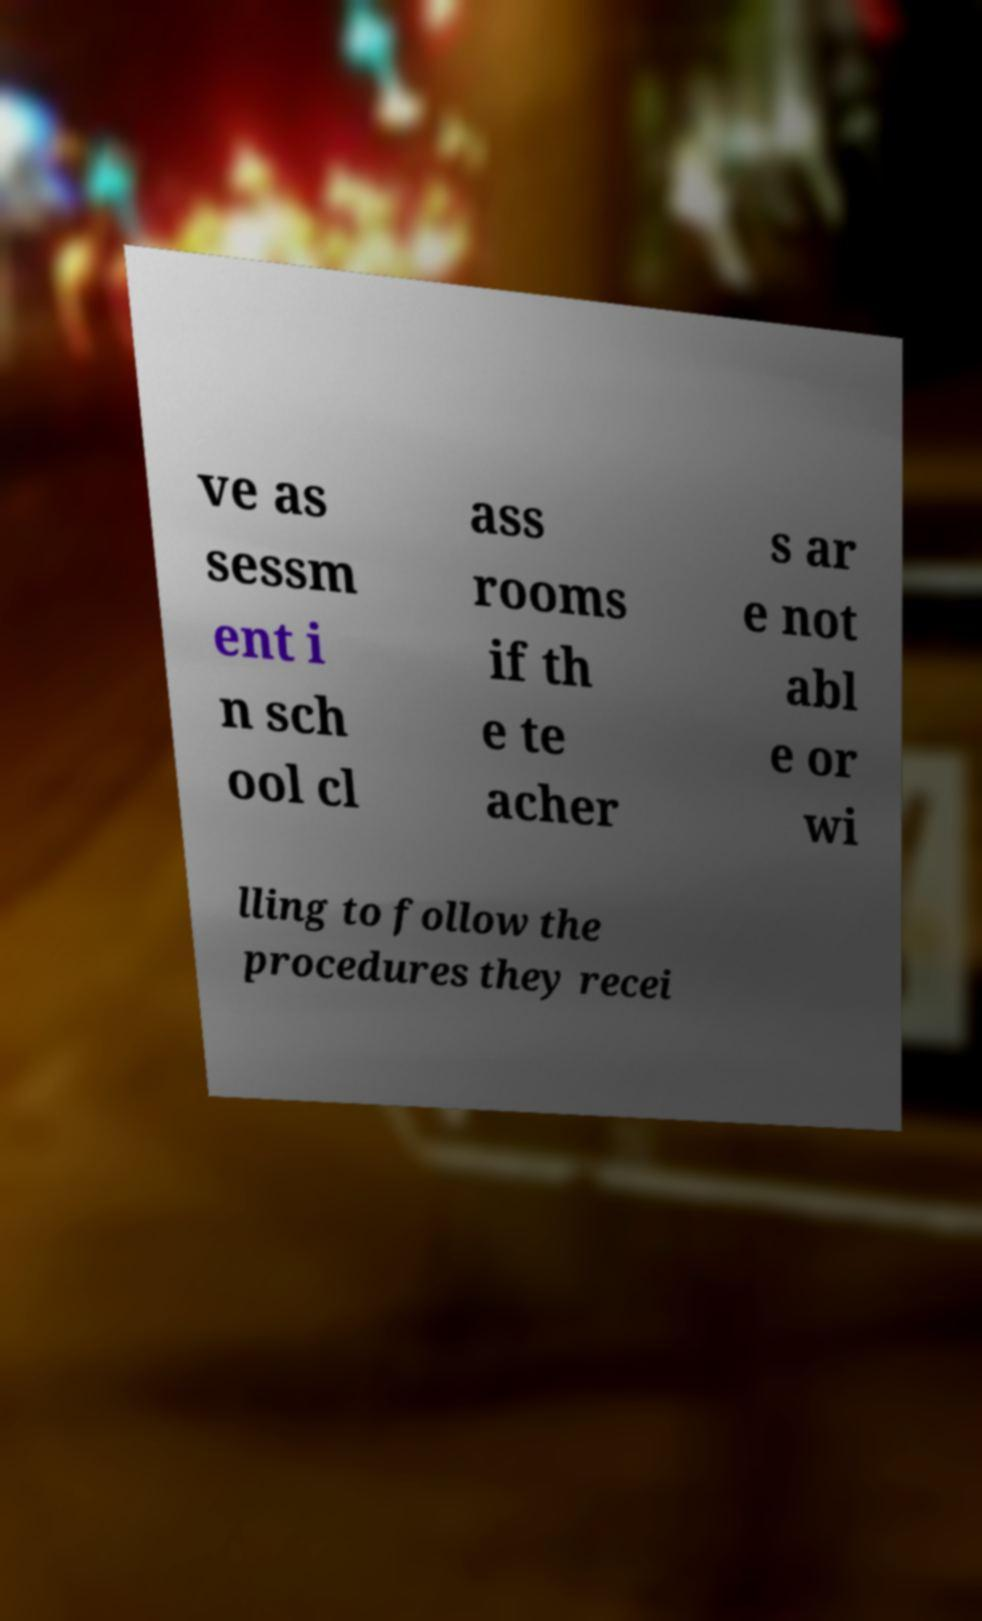For documentation purposes, I need the text within this image transcribed. Could you provide that? ve as sessm ent i n sch ool cl ass rooms if th e te acher s ar e not abl e or wi lling to follow the procedures they recei 